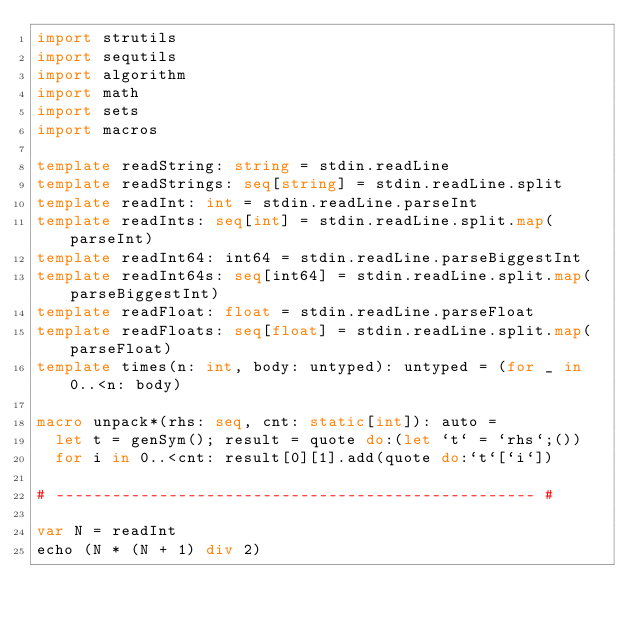Convert code to text. <code><loc_0><loc_0><loc_500><loc_500><_Nim_>import strutils
import sequtils
import algorithm
import math
import sets
import macros

template readString: string = stdin.readLine
template readStrings: seq[string] = stdin.readLine.split
template readInt: int = stdin.readLine.parseInt
template readInts: seq[int] = stdin.readLine.split.map(parseInt)
template readInt64: int64 = stdin.readLine.parseBiggestInt
template readInt64s: seq[int64] = stdin.readLine.split.map(parseBiggestInt)
template readFloat: float = stdin.readLine.parseFloat
template readFloats: seq[float] = stdin.readLine.split.map(parseFloat)
template times(n: int, body: untyped): untyped = (for _ in 0..<n: body)

macro unpack*(rhs: seq, cnt: static[int]): auto =
  let t = genSym(); result = quote do:(let `t` = `rhs`;())
  for i in 0..<cnt: result[0][1].add(quote do:`t`[`i`])

# --------------------------------------------------- #

var N = readInt
echo (N * (N + 1) div 2)</code> 